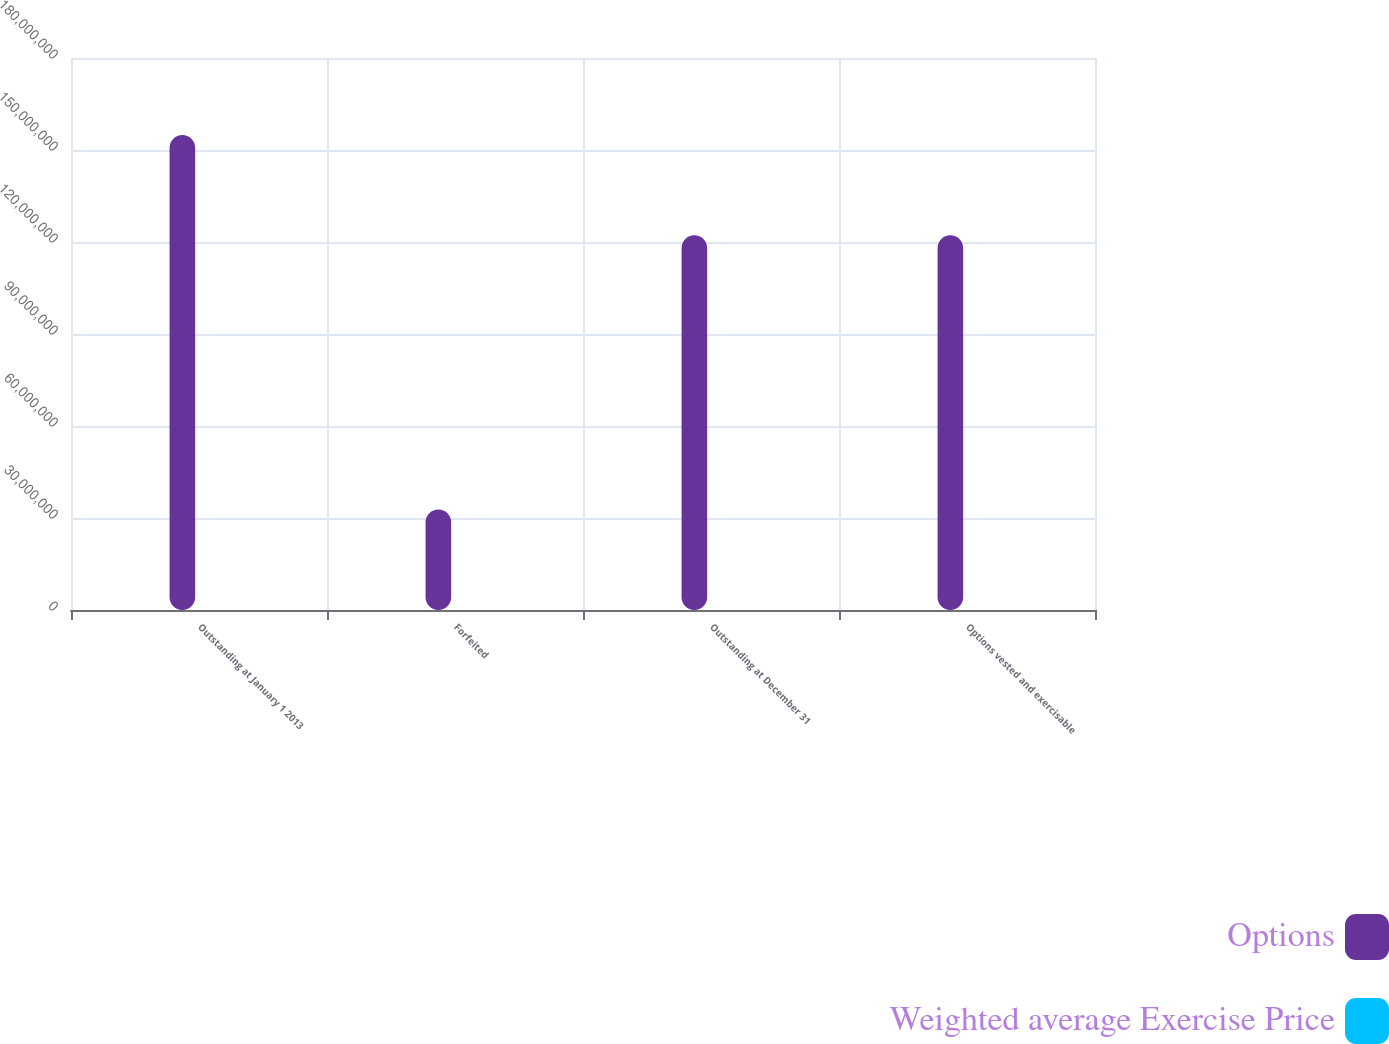Convert chart. <chart><loc_0><loc_0><loc_500><loc_500><stacked_bar_chart><ecel><fcel>Outstanding at January 1 2013<fcel>Forfeited<fcel>Outstanding at December 31<fcel>Options vested and exercisable<nl><fcel>Options<fcel>1.54924e+08<fcel>3.27549e+07<fcel>1.22169e+08<fcel>1.22169e+08<nl><fcel>Weighted average Exercise Price<fcel>46.22<fcel>38.73<fcel>48.23<fcel>48.23<nl></chart> 